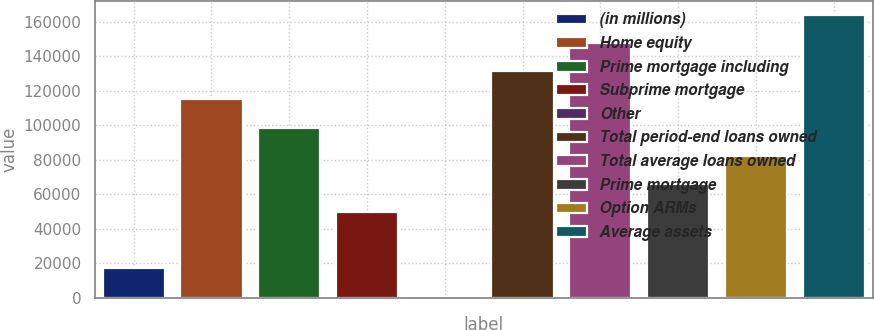Convert chart. <chart><loc_0><loc_0><loc_500><loc_500><bar_chart><fcel>(in millions)<fcel>Home equity<fcel>Prime mortgage including<fcel>Subprime mortgage<fcel>Other<fcel>Total period-end loans owned<fcel>Total average loans owned<fcel>Prime mortgage<fcel>Option ARMs<fcel>Average assets<nl><fcel>16885.7<fcel>114894<fcel>98559.2<fcel>49555.1<fcel>551<fcel>131229<fcel>147563<fcel>65889.8<fcel>82224.5<fcel>163898<nl></chart> 